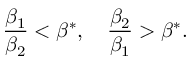<formula> <loc_0><loc_0><loc_500><loc_500>\frac { \beta _ { 1 } } { \beta _ { 2 } } < \beta ^ { * } , \quad \frac { \beta _ { 2 } } { \beta _ { 1 } } > \beta ^ { * } .</formula> 